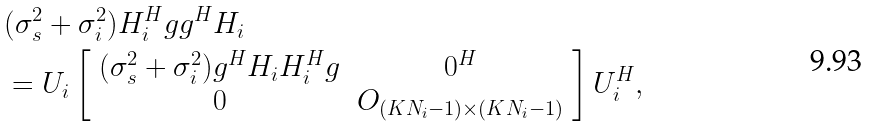Convert formula to latex. <formula><loc_0><loc_0><loc_500><loc_500>& ( \sigma _ { s } ^ { 2 } + \sigma _ { i } ^ { 2 } ) H _ { i } ^ { H } g g ^ { H } H _ { i } \\ & = U _ { i } \left [ \begin{array} { c c } ( \sigma _ { s } ^ { 2 } + \sigma _ { i } ^ { 2 } ) g ^ { H } H _ { i } H _ { i } ^ { H } g & 0 ^ { H } \\ 0 & O _ { ( K N _ { i } - 1 ) \times ( K N _ { i } - 1 ) } \end{array} \right ] U _ { i } ^ { H } ,</formula> 